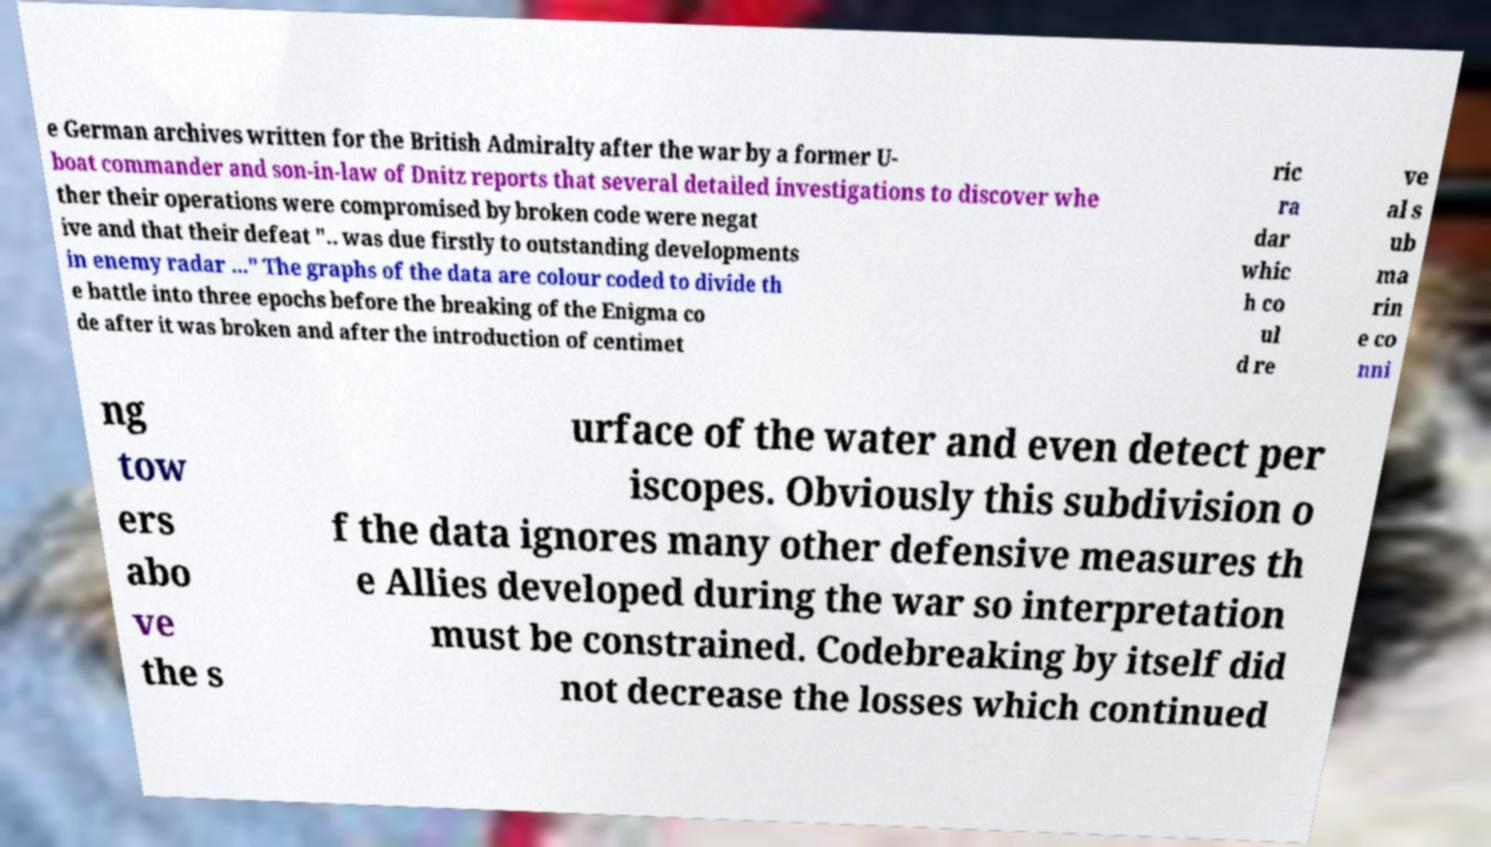For documentation purposes, I need the text within this image transcribed. Could you provide that? e German archives written for the British Admiralty after the war by a former U- boat commander and son-in-law of Dnitz reports that several detailed investigations to discover whe ther their operations were compromised by broken code were negat ive and that their defeat ".. was due firstly to outstanding developments in enemy radar ..." The graphs of the data are colour coded to divide th e battle into three epochs before the breaking of the Enigma co de after it was broken and after the introduction of centimet ric ra dar whic h co ul d re ve al s ub ma rin e co nni ng tow ers abo ve the s urface of the water and even detect per iscopes. Obviously this subdivision o f the data ignores many other defensive measures th e Allies developed during the war so interpretation must be constrained. Codebreaking by itself did not decrease the losses which continued 